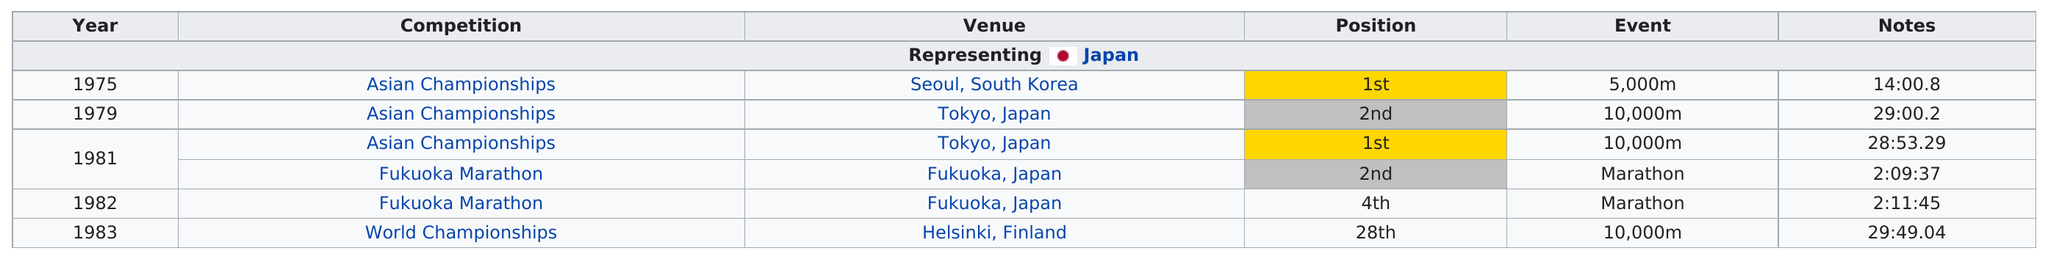Point out several critical features in this image. The World Championships came in last place out of all of the competitions shown. The Asian Championships, held in Tokyo, Japan, was a highly competitive event in which our team placed second. The 28th place was the least position won. Before he took 28th place in the 10,000m, Ito took first place in the same event. There have been 2 Fukuoka Marathons. 